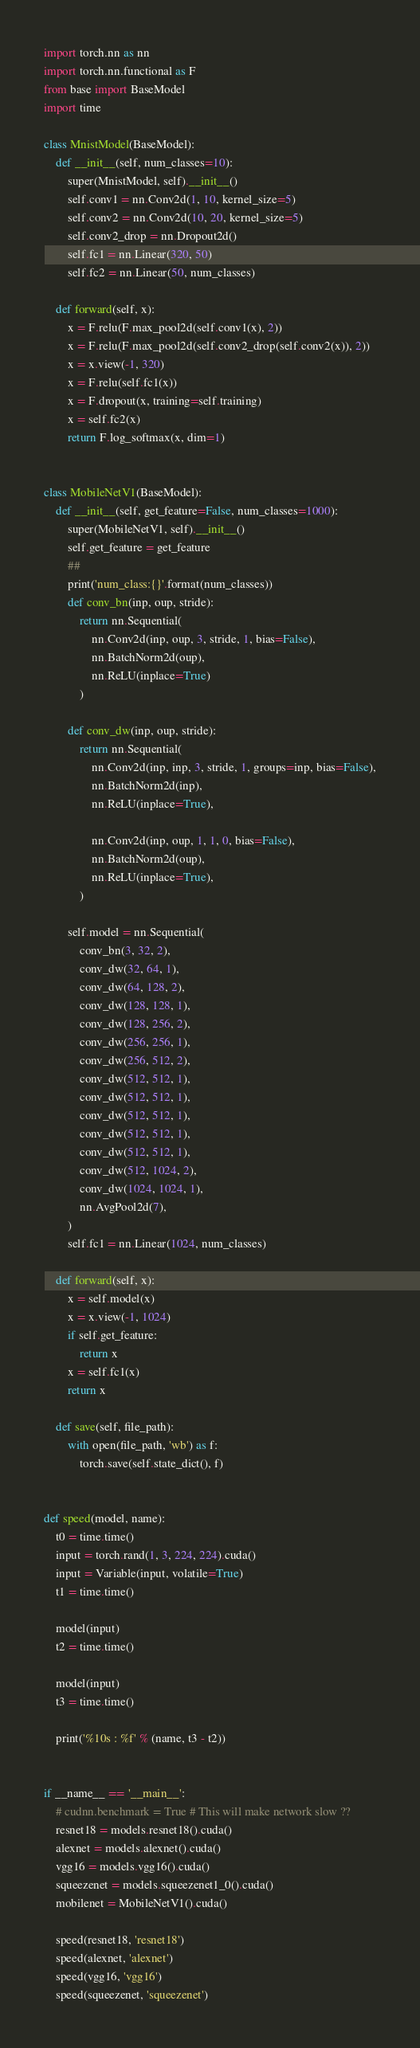Convert code to text. <code><loc_0><loc_0><loc_500><loc_500><_Python_>import torch.nn as nn
import torch.nn.functional as F
from base import BaseModel
import time

class MnistModel(BaseModel):
    def __init__(self, num_classes=10):
        super(MnistModel, self).__init__()
        self.conv1 = nn.Conv2d(1, 10, kernel_size=5)
        self.conv2 = nn.Conv2d(10, 20, kernel_size=5)
        self.conv2_drop = nn.Dropout2d()
        self.fc1 = nn.Linear(320, 50)
        self.fc2 = nn.Linear(50, num_classes)

    def forward(self, x):
        x = F.relu(F.max_pool2d(self.conv1(x), 2))
        x = F.relu(F.max_pool2d(self.conv2_drop(self.conv2(x)), 2))
        x = x.view(-1, 320)
        x = F.relu(self.fc1(x))
        x = F.dropout(x, training=self.training)
        x = self.fc2(x)
        return F.log_softmax(x, dim=1)


class MobileNetV1(BaseModel):
    def __init__(self, get_feature=False, num_classes=1000):
        super(MobileNetV1, self).__init__()
        self.get_feature = get_feature
        ##
        print('num_class:{}'.format(num_classes))
        def conv_bn(inp, oup, stride):
            return nn.Sequential(
                nn.Conv2d(inp, oup, 3, stride, 1, bias=False),
                nn.BatchNorm2d(oup),
                nn.ReLU(inplace=True)
            )

        def conv_dw(inp, oup, stride):
            return nn.Sequential(
                nn.Conv2d(inp, inp, 3, stride, 1, groups=inp, bias=False),
                nn.BatchNorm2d(inp),
                nn.ReLU(inplace=True),

                nn.Conv2d(inp, oup, 1, 1, 0, bias=False),
                nn.BatchNorm2d(oup),
                nn.ReLU(inplace=True),
            )

        self.model = nn.Sequential(
            conv_bn(3, 32, 2),
            conv_dw(32, 64, 1),
            conv_dw(64, 128, 2),
            conv_dw(128, 128, 1),
            conv_dw(128, 256, 2),
            conv_dw(256, 256, 1),
            conv_dw(256, 512, 2),
            conv_dw(512, 512, 1),
            conv_dw(512, 512, 1),
            conv_dw(512, 512, 1),
            conv_dw(512, 512, 1),
            conv_dw(512, 512, 1),
            conv_dw(512, 1024, 2),
            conv_dw(1024, 1024, 1),
            nn.AvgPool2d(7),
        )
        self.fc1 = nn.Linear(1024, num_classes)

    def forward(self, x):
        x = self.model(x)
        x = x.view(-1, 1024)
        if self.get_feature:
            return x
        x = self.fc1(x)
        return x

    def save(self, file_path):
        with open(file_path, 'wb') as f:
            torch.save(self.state_dict(), f)


def speed(model, name):
    t0 = time.time()
    input = torch.rand(1, 3, 224, 224).cuda()
    input = Variable(input, volatile=True)
    t1 = time.time()

    model(input)
    t2 = time.time()

    model(input)
    t3 = time.time()

    print('%10s : %f' % (name, t3 - t2))


if __name__ == '__main__':
    # cudnn.benchmark = True # This will make network slow ??
    resnet18 = models.resnet18().cuda()
    alexnet = models.alexnet().cuda()
    vgg16 = models.vgg16().cuda()
    squeezenet = models.squeezenet1_0().cuda()
    mobilenet = MobileNetV1().cuda()

    speed(resnet18, 'resnet18')
    speed(alexnet, 'alexnet')
    speed(vgg16, 'vgg16')
    speed(squeezenet, 'squeezenet')</code> 